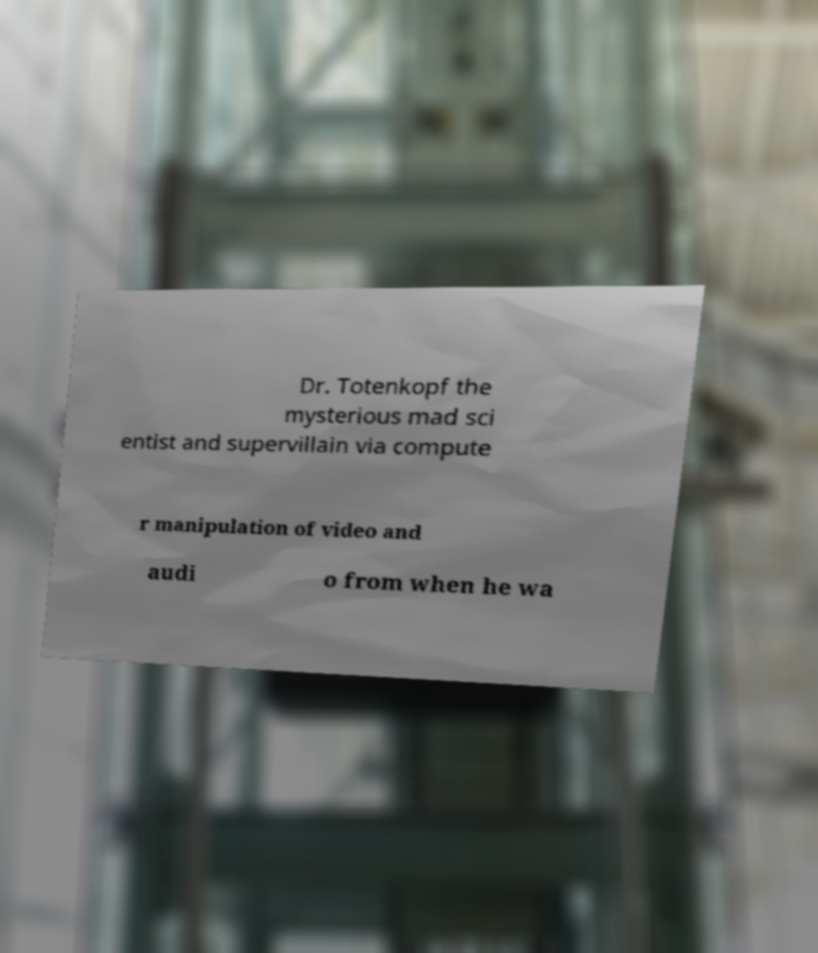Can you accurately transcribe the text from the provided image for me? Dr. Totenkopf the mysterious mad sci entist and supervillain via compute r manipulation of video and audi o from when he wa 